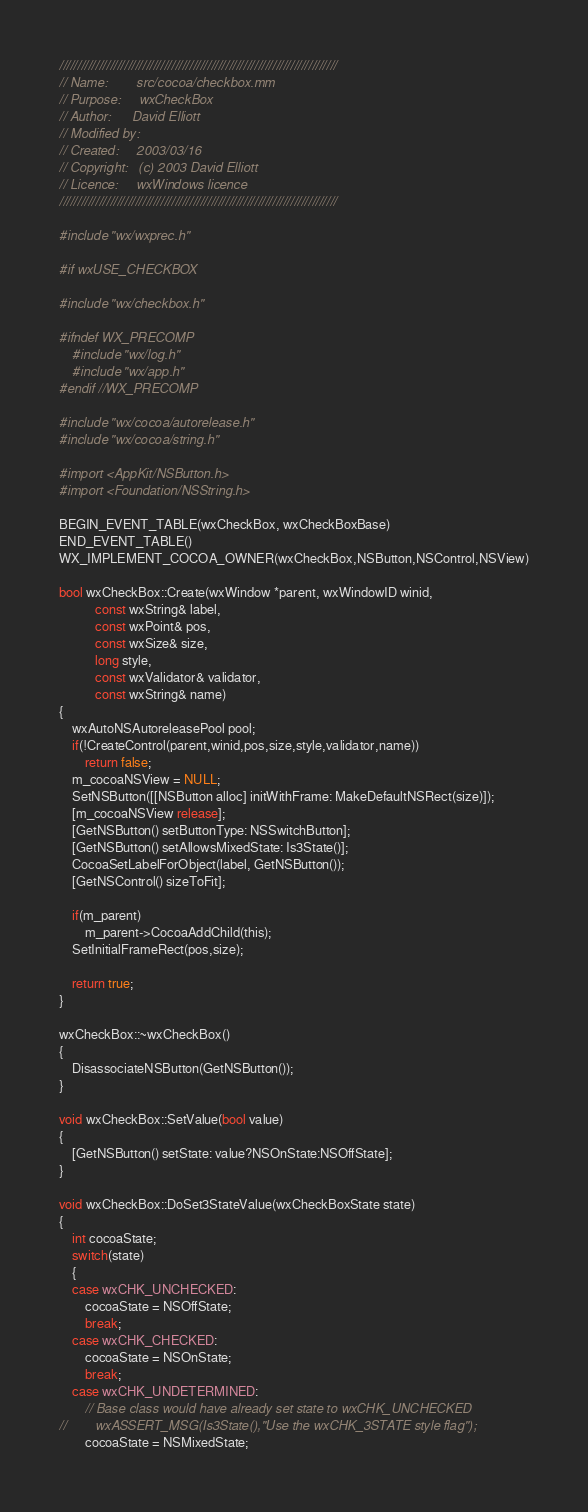Convert code to text. <code><loc_0><loc_0><loc_500><loc_500><_ObjectiveC_>/////////////////////////////////////////////////////////////////////////////
// Name:        src/cocoa/checkbox.mm
// Purpose:     wxCheckBox
// Author:      David Elliott
// Modified by:
// Created:     2003/03/16
// Copyright:   (c) 2003 David Elliott
// Licence:     wxWindows licence
/////////////////////////////////////////////////////////////////////////////

#include "wx/wxprec.h"

#if wxUSE_CHECKBOX

#include "wx/checkbox.h"

#ifndef WX_PRECOMP
    #include "wx/log.h"
    #include "wx/app.h"
#endif //WX_PRECOMP

#include "wx/cocoa/autorelease.h"
#include "wx/cocoa/string.h"

#import <AppKit/NSButton.h>
#import <Foundation/NSString.h>

BEGIN_EVENT_TABLE(wxCheckBox, wxCheckBoxBase)
END_EVENT_TABLE()
WX_IMPLEMENT_COCOA_OWNER(wxCheckBox,NSButton,NSControl,NSView)

bool wxCheckBox::Create(wxWindow *parent, wxWindowID winid,
           const wxString& label,
           const wxPoint& pos,
           const wxSize& size,
           long style,
           const wxValidator& validator,
           const wxString& name)
{
    wxAutoNSAutoreleasePool pool;
    if(!CreateControl(parent,winid,pos,size,style,validator,name))
        return false;
    m_cocoaNSView = NULL;
    SetNSButton([[NSButton alloc] initWithFrame: MakeDefaultNSRect(size)]);
    [m_cocoaNSView release];
    [GetNSButton() setButtonType: NSSwitchButton];
    [GetNSButton() setAllowsMixedState: Is3State()];
    CocoaSetLabelForObject(label, GetNSButton());
    [GetNSControl() sizeToFit];

    if(m_parent)
        m_parent->CocoaAddChild(this);
    SetInitialFrameRect(pos,size);

    return true;
}

wxCheckBox::~wxCheckBox()
{
    DisassociateNSButton(GetNSButton());
}

void wxCheckBox::SetValue(bool value)
{
    [GetNSButton() setState: value?NSOnState:NSOffState];
}

void wxCheckBox::DoSet3StateValue(wxCheckBoxState state)
{
    int cocoaState;
    switch(state)
    {
    case wxCHK_UNCHECKED:
        cocoaState = NSOffState;
        break;
    case wxCHK_CHECKED:
        cocoaState = NSOnState;
        break;
    case wxCHK_UNDETERMINED:
        // Base class would have already set state to wxCHK_UNCHECKED
//        wxASSERT_MSG(Is3State(),"Use the wxCHK_3STATE style flag");
        cocoaState = NSMixedState;</code> 